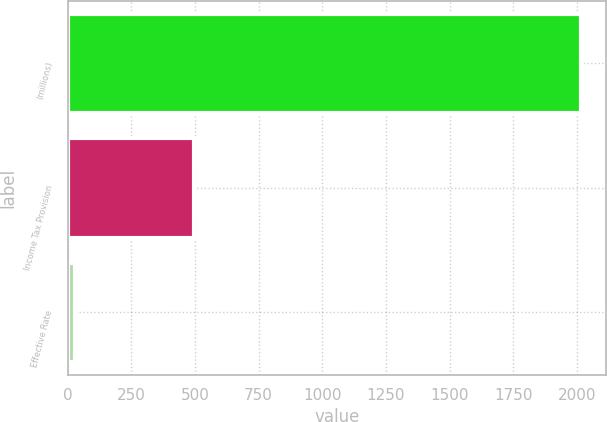Convert chart. <chart><loc_0><loc_0><loc_500><loc_500><bar_chart><fcel>(millions)<fcel>Income Tax Provision<fcel>Effective Rate<nl><fcel>2014<fcel>496<fcel>29<nl></chart> 